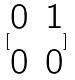Convert formula to latex. <formula><loc_0><loc_0><loc_500><loc_500>[ \begin{matrix} 0 & 1 \\ 0 & 0 \end{matrix} ]</formula> 